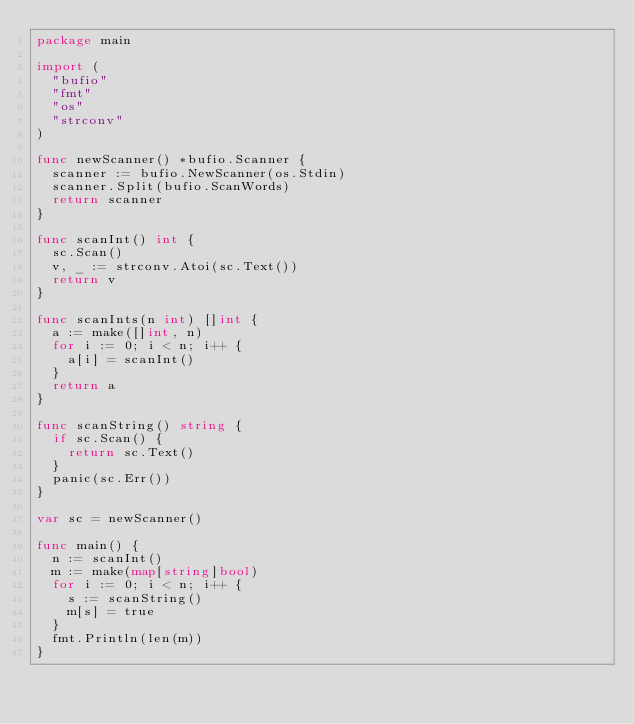Convert code to text. <code><loc_0><loc_0><loc_500><loc_500><_Go_>package main

import (
	"bufio"
	"fmt"
	"os"
	"strconv"
)

func newScanner() *bufio.Scanner {
	scanner := bufio.NewScanner(os.Stdin)
	scanner.Split(bufio.ScanWords)
	return scanner
}

func scanInt() int {
	sc.Scan()
	v, _ := strconv.Atoi(sc.Text())
	return v
}

func scanInts(n int) []int {
	a := make([]int, n)
	for i := 0; i < n; i++ {
		a[i] = scanInt()
	}
	return a
}

func scanString() string {
	if sc.Scan() {
		return sc.Text()
	}
	panic(sc.Err())
}

var sc = newScanner()

func main() {
	n := scanInt()
	m := make(map[string]bool)
	for i := 0; i < n; i++ {
		s := scanString()
		m[s] = true
	}
	fmt.Println(len(m))
}
</code> 